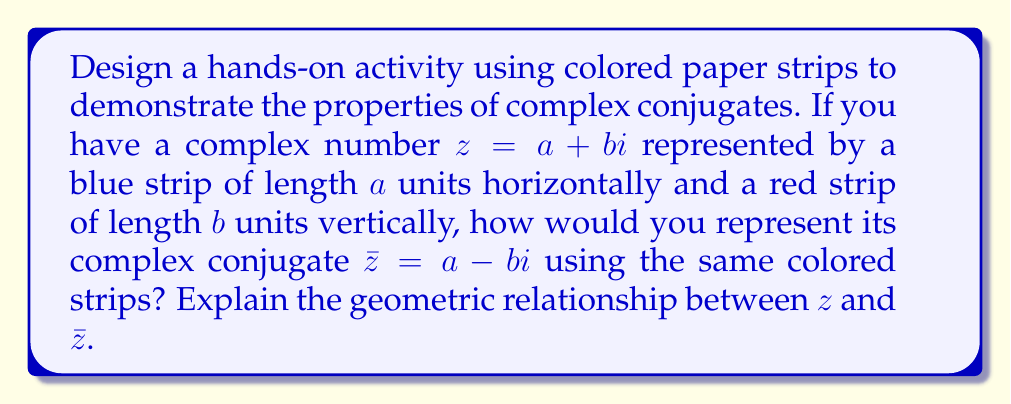Solve this math problem. Let's approach this step-by-step:

1) First, let's visualize the complex number $z = a + bi$:
   - Use a blue strip of length $a$ units horizontally (representing the real part)
   - Attach a red strip of length $b$ units vertically at the end of the blue strip (representing the imaginary part)

2) Now, for the complex conjugate $\bar{z} = a - bi$:
   - The blue strip remains the same, as the real part $a$ doesn't change
   - The red strip should be of the same length $b$, but pointing downwards instead of upwards

3) The geometric relationship between $z$ and $\bar{z}$:
   - They have the same distance from the real axis (x-axis)
   - They are symmetric about the real axis

4) To demonstrate this symmetry:
   - Place the representation of $z$ above the x-axis
   - Place the representation of $\bar{z}$ below the x-axis, with blue strips aligned

5) Properties to observe:
   - The blue strips (real parts) align perfectly
   - The red strips (imaginary parts) are mirror images of each other
   - If you fold the paper along the real axis, the two representations would overlap perfectly

This hands-on activity helps visualize that complex conjugates have the same real part but opposite imaginary parts, and they are mirror images of each other about the real axis.
Answer: Reflect the vertical red strip across the horizontal axis while keeping the horizontal blue strip in the same position. 